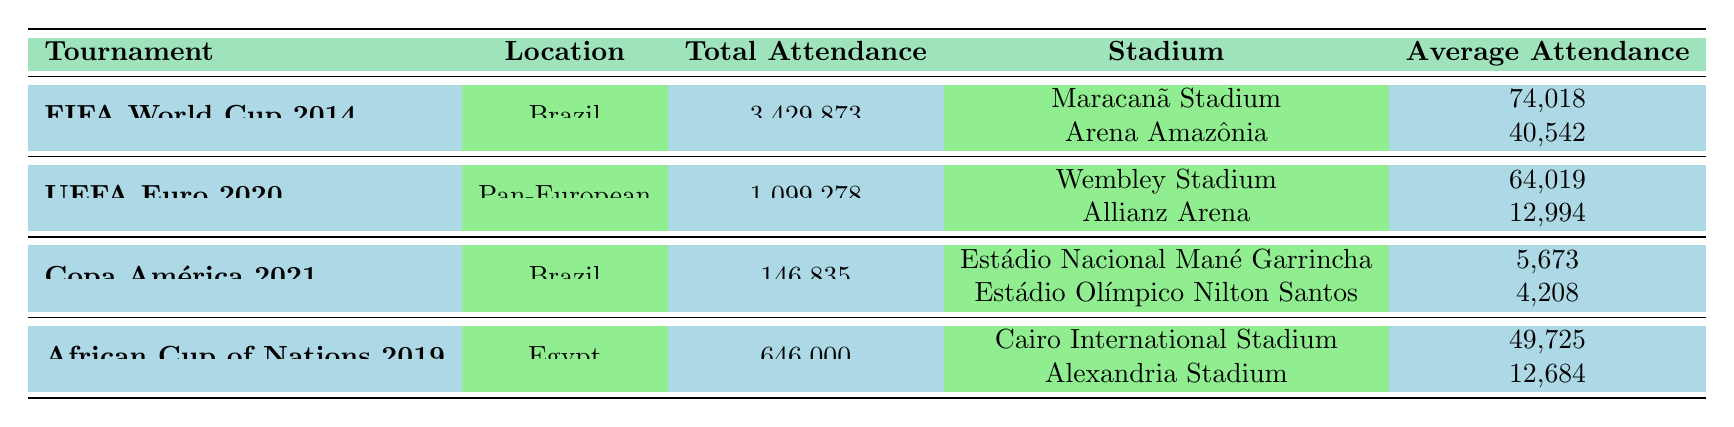What was the total attendance for the FIFA World Cup 2014? The table lists the total attendance for the FIFA World Cup 2014 as 3,429,873.
Answer: 3,429,873 Which stadium had the highest average attendance during the UEFA Euro 2020? In the UEFA Euro 2020 section, Wembley Stadium has an average attendance of 64,019, which is higher than Allianz Arena's average attendance of 12,994.
Answer: Wembley Stadium What is the capacity of the Cairo International Stadium? The table shows that the capacity of the Cairo International Stadium is 75,000.
Answer: 75,000 How much higher was the total attendance of the FIFA World Cup 2014 compared to the Copa América 2021? The total attendance for the FIFA World Cup 2014 is 3,429,873 and for Copa América 2021 is 146,835. The difference is 3,429,873 - 146,835 = 3,283,038.
Answer: 3,283,038 What is the average attendance of all stadiums listed under the Copa América 2021? The average attendance for Estádio Nacional Mané Garrincha is 5,673 and for Estádio Olímpico Nilton Santos is 4,208. The sum is 5,673 + 4,208 = 9,881, and dividing by 2 gives an average of 4,940.5.
Answer: 4,940.5 Is the average attendance at Arena Amazônia higher than that at Estádio Olímpico Nilton Santos? Arena Amazônia's average attendance is 40,542 while Estádio Olímpico Nilton Santos has 4,208. Since 40,542 is greater than 4,208, the statement is true.
Answer: Yes Which tournament had the least total attendance, and what was the figure? The Copa América 2021 had the least total attendance at 146,835 compared to the others listed in the table.
Answer: Copa América 2021: 146,835 What is the combined average attendance of all stadiums in the African Cup of Nations 2019? The average attendance for Cairo International Stadium is 49,725 and Alexandria Stadium is 12,684. Their total is 49,725 + 12,684 = 62,409, and dividing by 2 gives an average of 31,204.5.
Answer: 31,204.5 Which location had the highest total attendance across all the tournaments listed? The FIFA World Cup 2014 with a total attendance of 3,429,873 is higher than all the other tournaments listed.
Answer: Brazil (FIFA World Cup 2014) How many stadiums were used in the UEFA Euro 2020, and what was the average attendance across them? There are two stadiums: Wembley Stadium and Allianz Arena. Their average attendance is (64,019 + 12,994) / 2 = 38,006.5.
Answer: 2 stadiums, average 38,006.5 